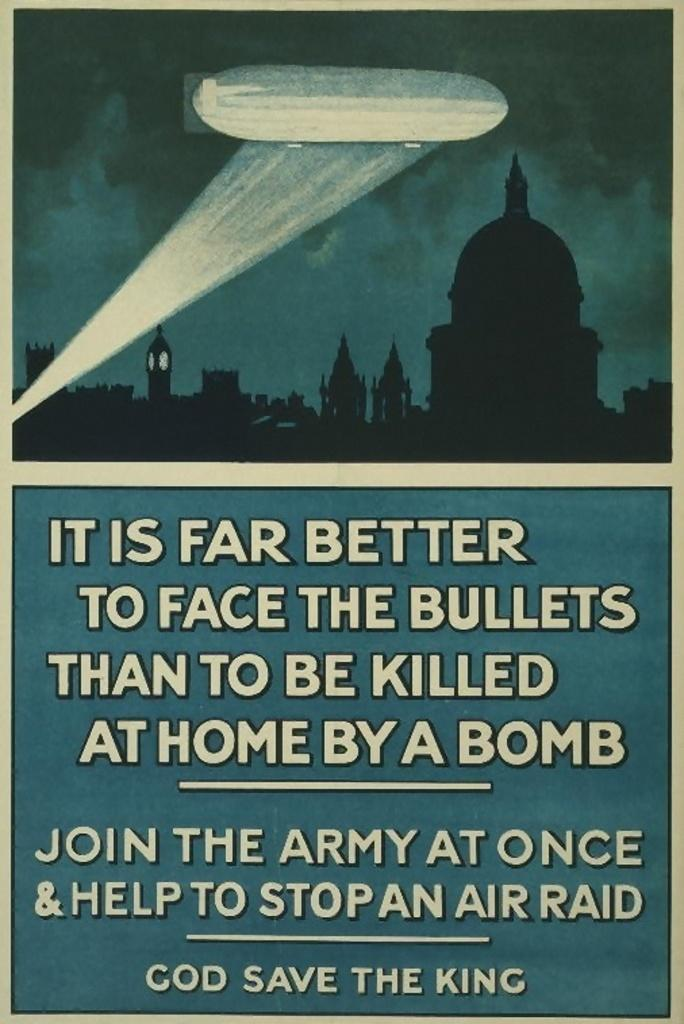<image>
Create a compact narrative representing the image presented. a poster that says God save the king 